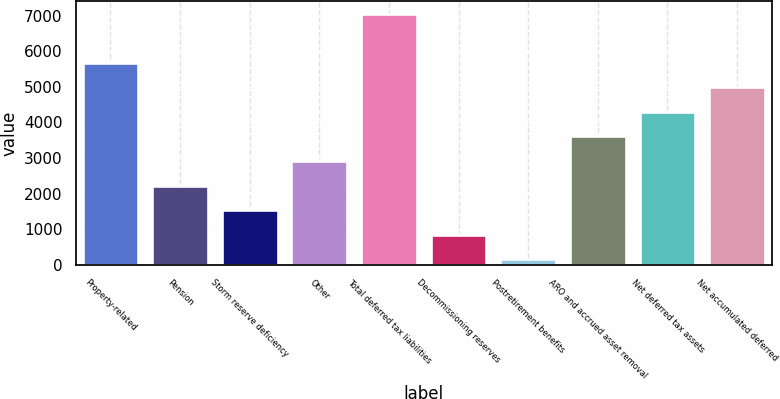Convert chart. <chart><loc_0><loc_0><loc_500><loc_500><bar_chart><fcel>Property-related<fcel>Pension<fcel>Storm reserve deficiency<fcel>Other<fcel>Total deferred tax liabilities<fcel>Decommissioning reserves<fcel>Postretirement benefits<fcel>ARO and accrued asset removal<fcel>Net deferred tax assets<fcel>Net accumulated deferred<nl><fcel>5674.6<fcel>2226.1<fcel>1536.4<fcel>2915.8<fcel>7054<fcel>846.7<fcel>157<fcel>3605.5<fcel>4295.2<fcel>4984.9<nl></chart> 